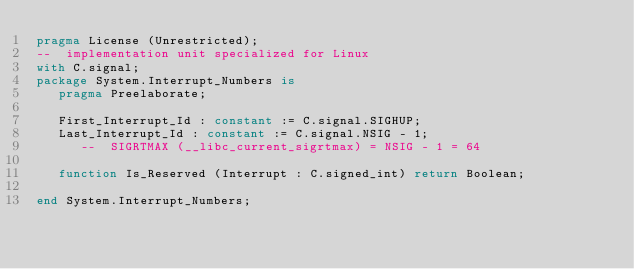<code> <loc_0><loc_0><loc_500><loc_500><_Ada_>pragma License (Unrestricted);
--  implementation unit specialized for Linux
with C.signal;
package System.Interrupt_Numbers is
   pragma Preelaborate;

   First_Interrupt_Id : constant := C.signal.SIGHUP;
   Last_Interrupt_Id : constant := C.signal.NSIG - 1;
      --  SIGRTMAX (__libc_current_sigrtmax) = NSIG - 1 = 64

   function Is_Reserved (Interrupt : C.signed_int) return Boolean;

end System.Interrupt_Numbers;
</code> 